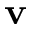<formula> <loc_0><loc_0><loc_500><loc_500>v</formula> 